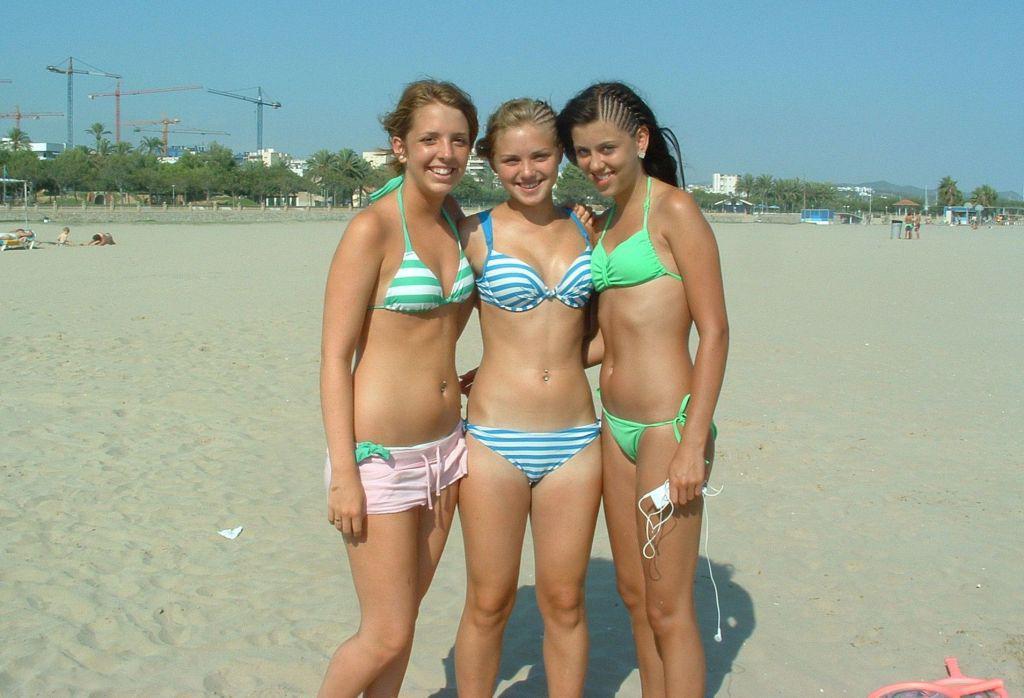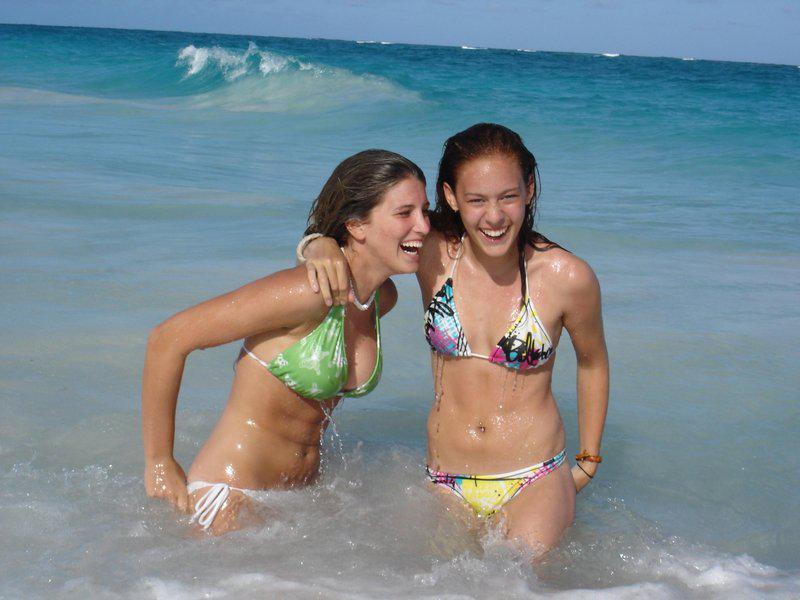The first image is the image on the left, the second image is the image on the right. Examine the images to the left and right. Is the description "There are four girls wearing swimsuits at the beach in one of the images." accurate? Answer yes or no. No. The first image is the image on the left, the second image is the image on the right. Examine the images to the left and right. Is the description "There are seven girls." accurate? Answer yes or no. No. 